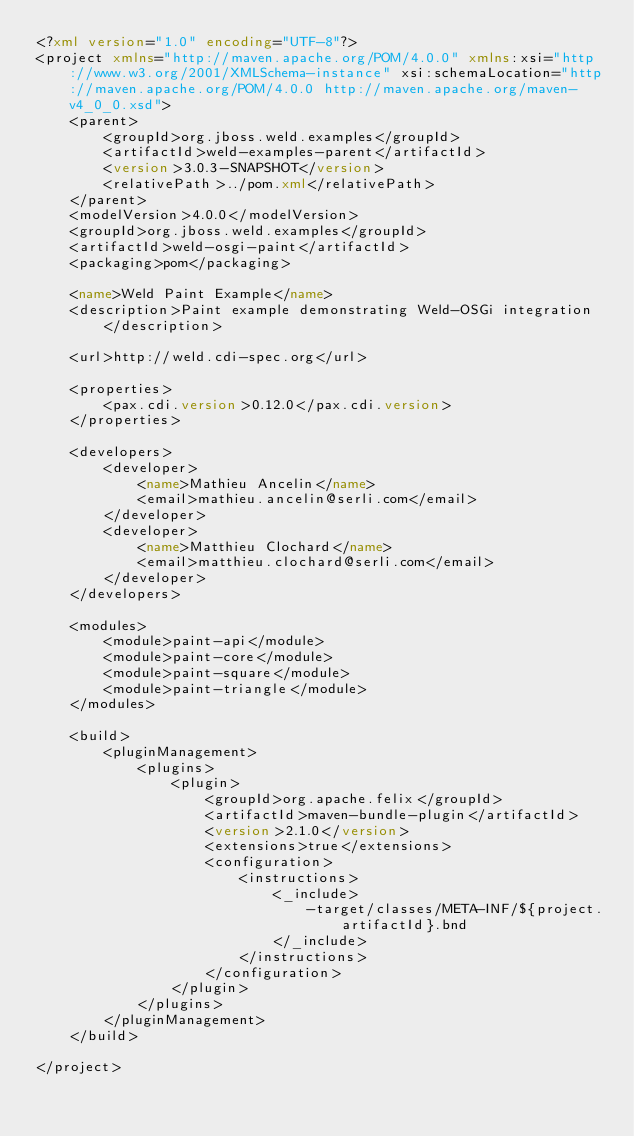<code> <loc_0><loc_0><loc_500><loc_500><_XML_><?xml version="1.0" encoding="UTF-8"?>
<project xmlns="http://maven.apache.org/POM/4.0.0" xmlns:xsi="http://www.w3.org/2001/XMLSchema-instance" xsi:schemaLocation="http://maven.apache.org/POM/4.0.0 http://maven.apache.org/maven-v4_0_0.xsd">
    <parent>
        <groupId>org.jboss.weld.examples</groupId>
        <artifactId>weld-examples-parent</artifactId>
        <version>3.0.3-SNAPSHOT</version>
        <relativePath>../pom.xml</relativePath>
    </parent>
    <modelVersion>4.0.0</modelVersion>
    <groupId>org.jboss.weld.examples</groupId>
    <artifactId>weld-osgi-paint</artifactId>
    <packaging>pom</packaging>

    <name>Weld Paint Example</name>
    <description>Paint example demonstrating Weld-OSGi integration</description>

    <url>http://weld.cdi-spec.org</url>

    <properties>
        <pax.cdi.version>0.12.0</pax.cdi.version>
    </properties>

    <developers>
        <developer>
            <name>Mathieu Ancelin</name>
            <email>mathieu.ancelin@serli.com</email>
        </developer>
        <developer>
            <name>Matthieu Clochard</name>
            <email>matthieu.clochard@serli.com</email>
        </developer>
    </developers>

    <modules>
        <module>paint-api</module>
        <module>paint-core</module>
        <module>paint-square</module>
        <module>paint-triangle</module>
    </modules>

    <build>
        <pluginManagement>
            <plugins>
                <plugin>
                    <groupId>org.apache.felix</groupId>
                    <artifactId>maven-bundle-plugin</artifactId>
                    <version>2.1.0</version>
                    <extensions>true</extensions>
                    <configuration>
                        <instructions>
                            <_include>
                                -target/classes/META-INF/${project.artifactId}.bnd
                            </_include>
                        </instructions>
                    </configuration>
                </plugin>
            </plugins>
        </pluginManagement>
    </build>

</project>
</code> 